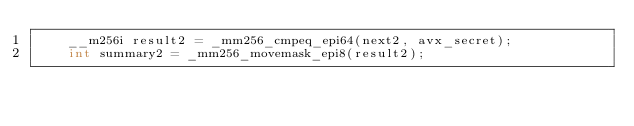Convert code to text. <code><loc_0><loc_0><loc_500><loc_500><_C_>    __m256i result2 = _mm256_cmpeq_epi64(next2, avx_secret);
    int summary2 = _mm256_movemask_epi8(result2);
</code> 